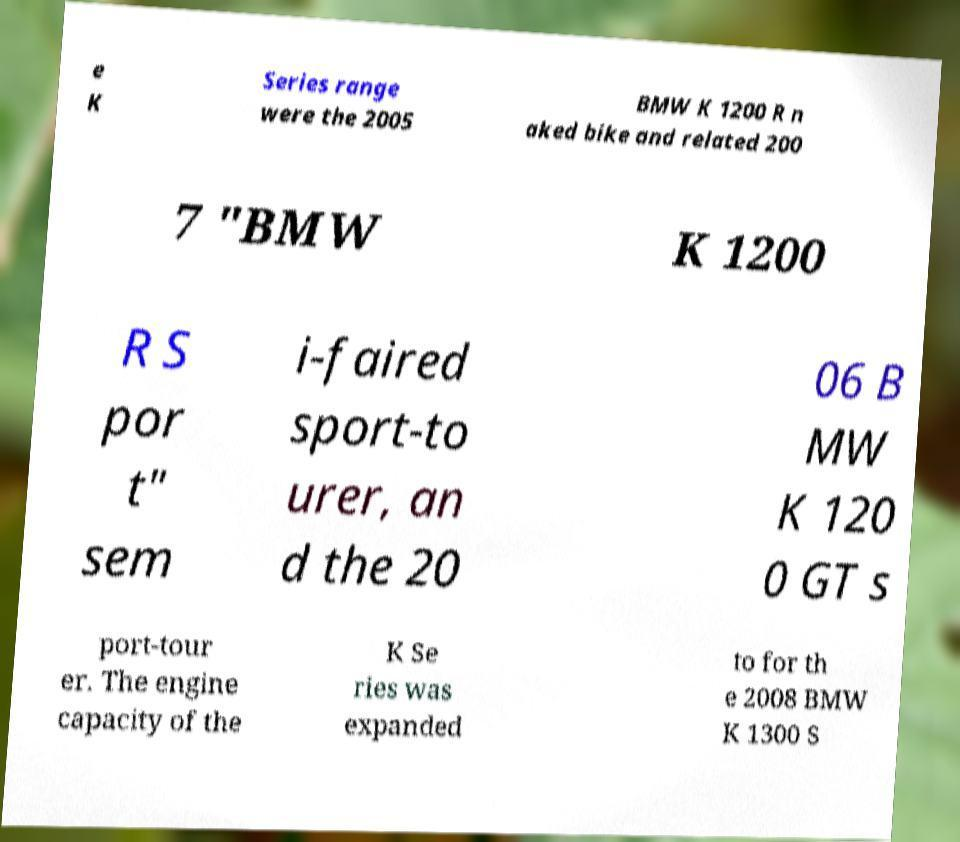Please identify and transcribe the text found in this image. e K Series range were the 2005 BMW K 1200 R n aked bike and related 200 7 "BMW K 1200 R S por t" sem i-faired sport-to urer, an d the 20 06 B MW K 120 0 GT s port-tour er. The engine capacity of the K Se ries was expanded to for th e 2008 BMW K 1300 S 